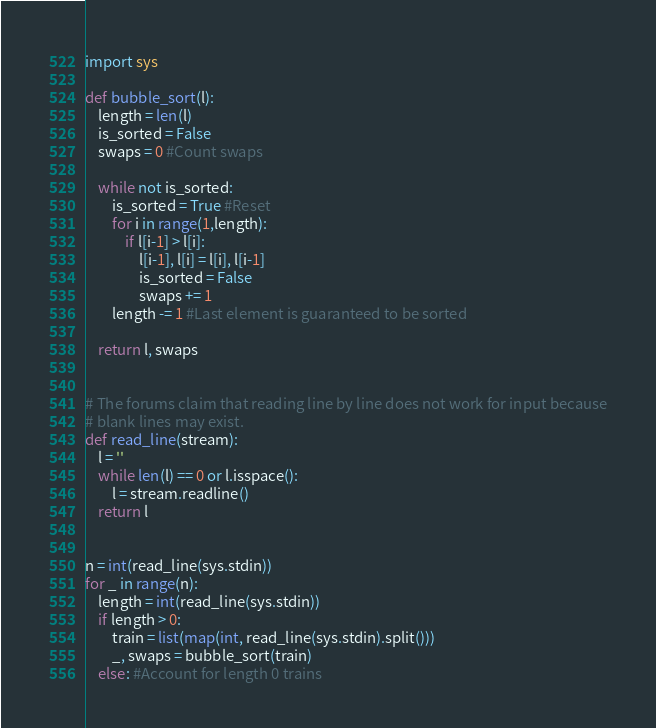<code> <loc_0><loc_0><loc_500><loc_500><_Python_>import sys

def bubble_sort(l):
    length = len(l)
    is_sorted = False
    swaps = 0 #Count swaps

    while not is_sorted:
        is_sorted = True #Reset
        for i in range(1,length):
            if l[i-1] > l[i]:
                l[i-1], l[i] = l[i], l[i-1]
                is_sorted = False
                swaps += 1
        length -= 1 #Last element is guaranteed to be sorted

    return l, swaps


# The forums claim that reading line by line does not work for input because
# blank lines may exist.
def read_line(stream):
    l = ''
    while len(l) == 0 or l.isspace():
        l = stream.readline()
    return l


n = int(read_line(sys.stdin))
for _ in range(n):
    length = int(read_line(sys.stdin))
    if length > 0:
        train = list(map(int, read_line(sys.stdin).split()))
        _, swaps = bubble_sort(train)
    else: #Account for length 0 trains</code> 